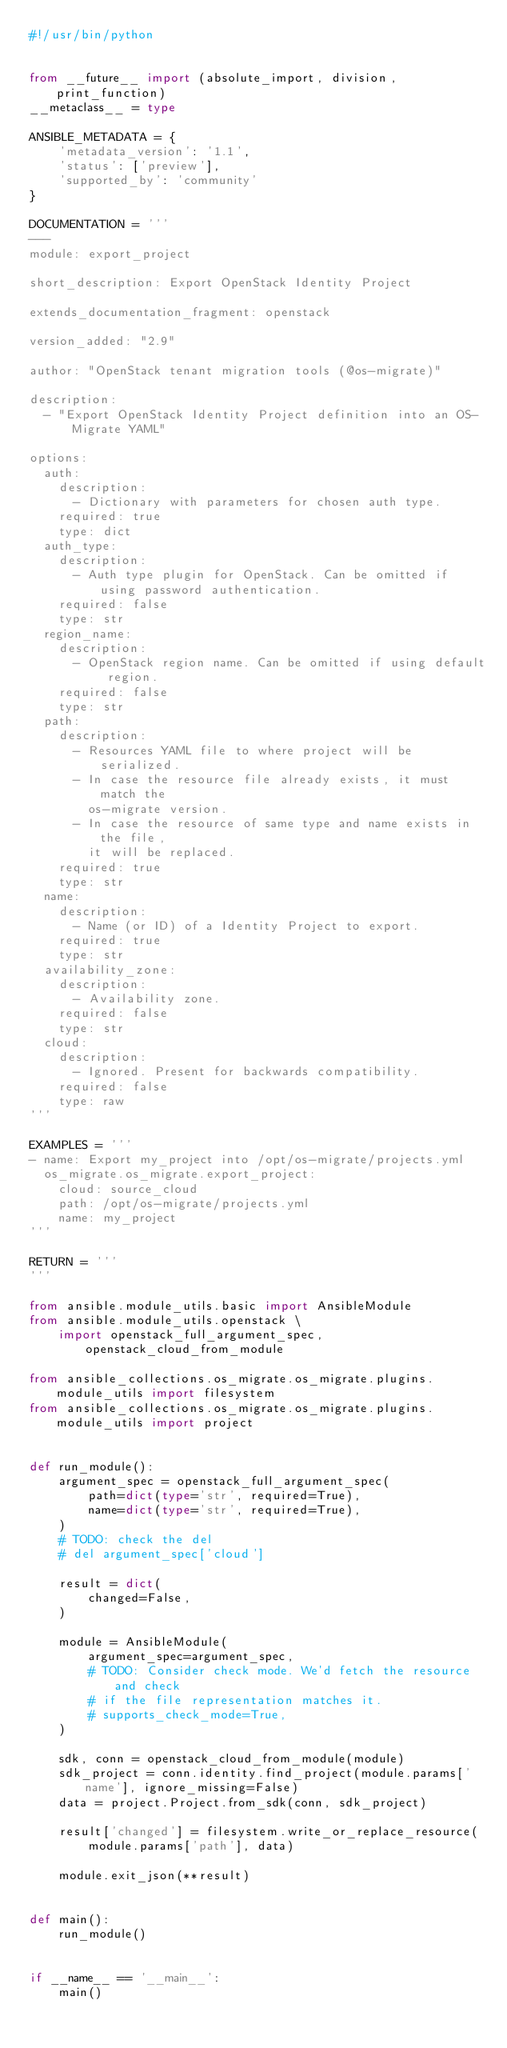<code> <loc_0><loc_0><loc_500><loc_500><_Python_>#!/usr/bin/python


from __future__ import (absolute_import, division, print_function)
__metaclass__ = type

ANSIBLE_METADATA = {
    'metadata_version': '1.1',
    'status': ['preview'],
    'supported_by': 'community'
}

DOCUMENTATION = '''
---
module: export_project

short_description: Export OpenStack Identity Project

extends_documentation_fragment: openstack

version_added: "2.9"

author: "OpenStack tenant migration tools (@os-migrate)"

description:
  - "Export OpenStack Identity Project definition into an OS-Migrate YAML"

options:
  auth:
    description:
      - Dictionary with parameters for chosen auth type.
    required: true
    type: dict
  auth_type:
    description:
      - Auth type plugin for OpenStack. Can be omitted if using password authentication.
    required: false
    type: str
  region_name:
    description:
      - OpenStack region name. Can be omitted if using default region.
    required: false
    type: str
  path:
    description:
      - Resources YAML file to where project will be serialized.
      - In case the resource file already exists, it must match the
        os-migrate version.
      - In case the resource of same type and name exists in the file,
        it will be replaced.
    required: true
    type: str
  name:
    description:
      - Name (or ID) of a Identity Project to export.
    required: true
    type: str
  availability_zone:
    description:
      - Availability zone.
    required: false
    type: str
  cloud:
    description:
      - Ignored. Present for backwards compatibility.
    required: false
    type: raw
'''

EXAMPLES = '''
- name: Export my_project into /opt/os-migrate/projects.yml
  os_migrate.os_migrate.export_project:
    cloud: source_cloud
    path: /opt/os-migrate/projects.yml
    name: my_project
'''

RETURN = '''
'''

from ansible.module_utils.basic import AnsibleModule
from ansible.module_utils.openstack \
    import openstack_full_argument_spec, openstack_cloud_from_module

from ansible_collections.os_migrate.os_migrate.plugins.module_utils import filesystem
from ansible_collections.os_migrate.os_migrate.plugins.module_utils import project


def run_module():
    argument_spec = openstack_full_argument_spec(
        path=dict(type='str', required=True),
        name=dict(type='str', required=True),
    )
    # TODO: check the del
    # del argument_spec['cloud']

    result = dict(
        changed=False,
    )

    module = AnsibleModule(
        argument_spec=argument_spec,
        # TODO: Consider check mode. We'd fetch the resource and check
        # if the file representation matches it.
        # supports_check_mode=True,
    )

    sdk, conn = openstack_cloud_from_module(module)
    sdk_project = conn.identity.find_project(module.params['name'], ignore_missing=False)
    data = project.Project.from_sdk(conn, sdk_project)

    result['changed'] = filesystem.write_or_replace_resource(
        module.params['path'], data)

    module.exit_json(**result)


def main():
    run_module()


if __name__ == '__main__':
    main()
</code> 